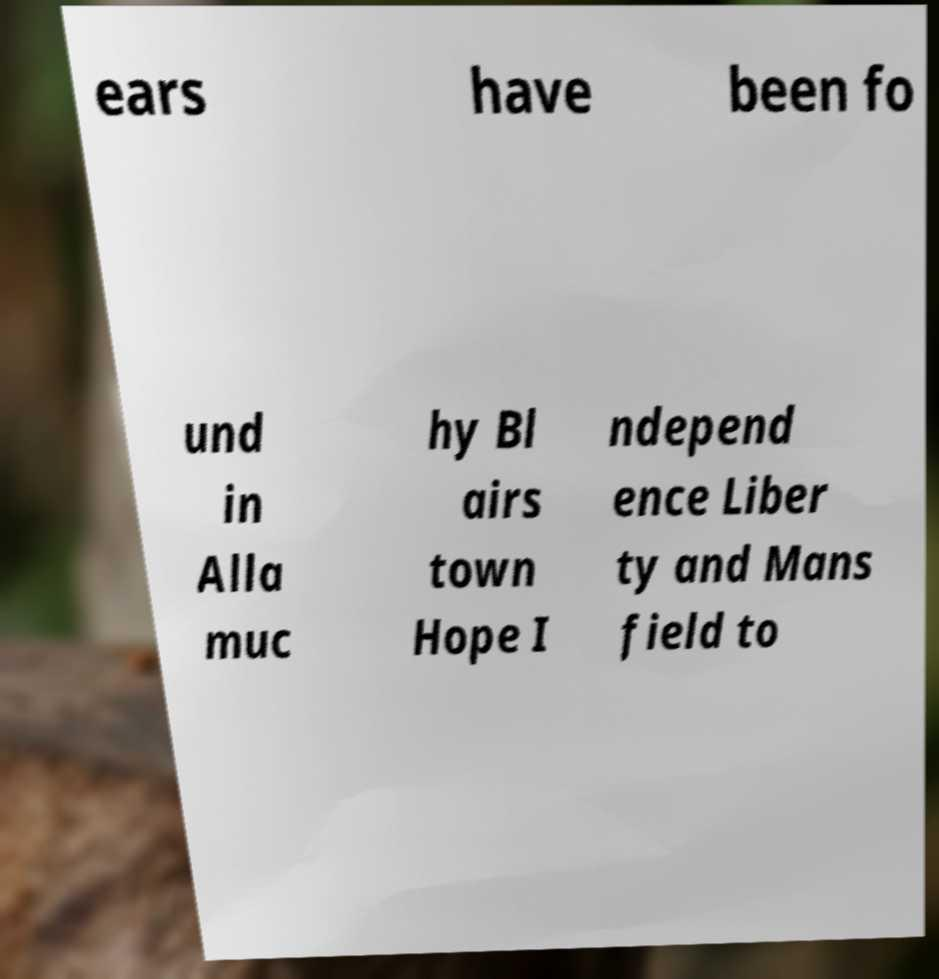Please identify and transcribe the text found in this image. ears have been fo und in Alla muc hy Bl airs town Hope I ndepend ence Liber ty and Mans field to 